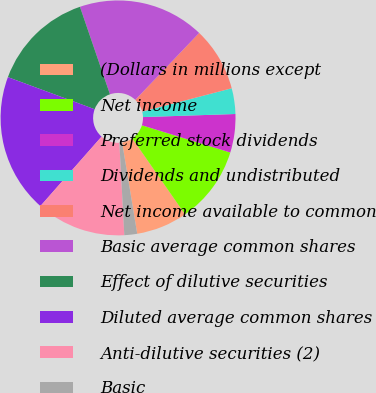<chart> <loc_0><loc_0><loc_500><loc_500><pie_chart><fcel>(Dollars in millions except<fcel>Net income<fcel>Preferred stock dividends<fcel>Dividends and undistributed<fcel>Net income available to common<fcel>Basic average common shares<fcel>Effect of dilutive securities<fcel>Diluted average common shares<fcel>Anti-dilutive securities (2)<fcel>Basic<nl><fcel>7.05%<fcel>10.58%<fcel>5.29%<fcel>3.53%<fcel>8.81%<fcel>17.39%<fcel>14.1%<fcel>19.15%<fcel>12.34%<fcel>1.76%<nl></chart> 